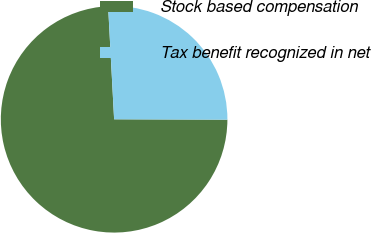Convert chart. <chart><loc_0><loc_0><loc_500><loc_500><pie_chart><fcel>Stock based compensation<fcel>Tax benefit recognized in net<nl><fcel>74.1%<fcel>25.9%<nl></chart> 